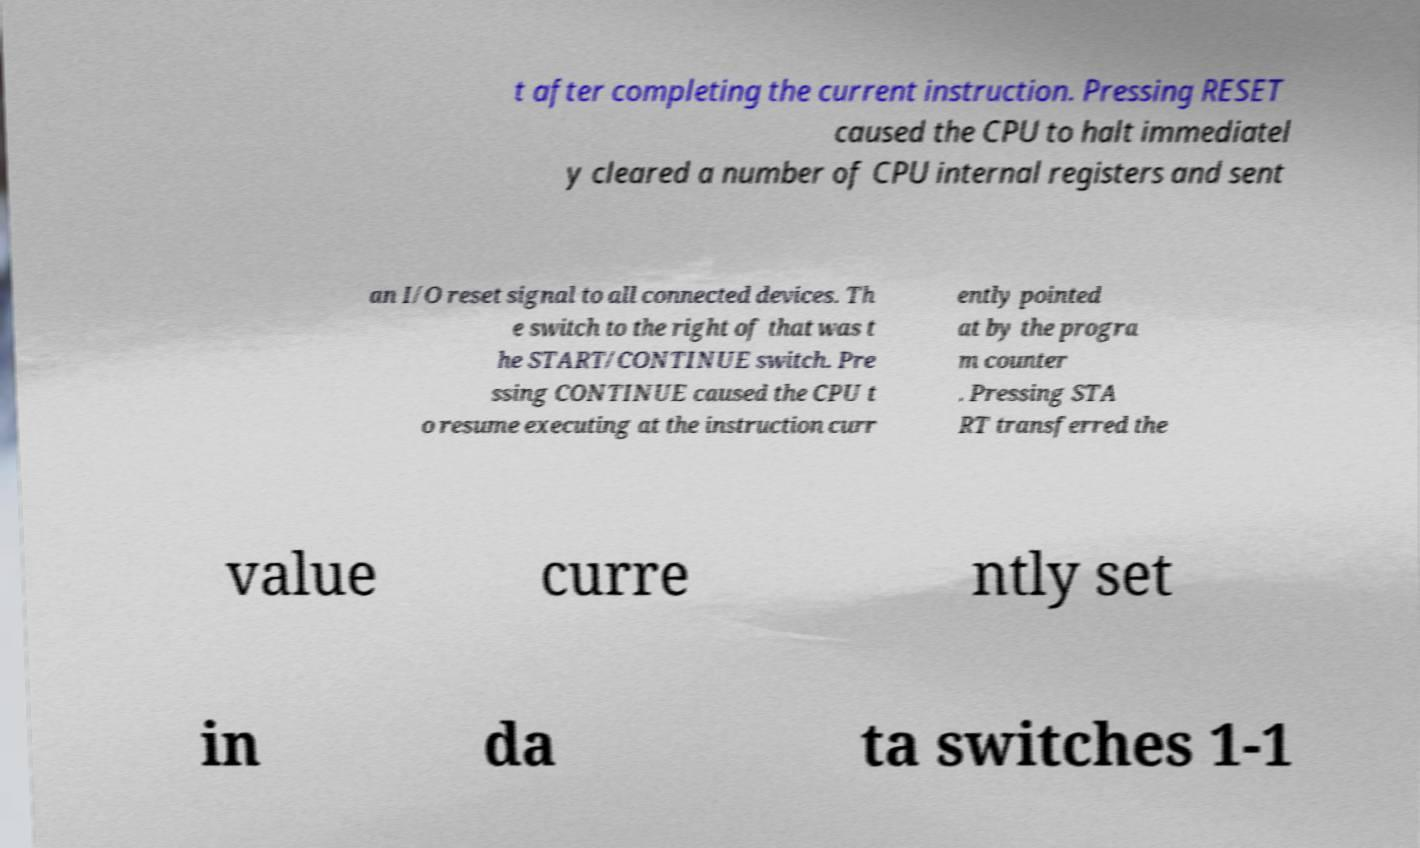I need the written content from this picture converted into text. Can you do that? t after completing the current instruction. Pressing RESET caused the CPU to halt immediatel y cleared a number of CPU internal registers and sent an I/O reset signal to all connected devices. Th e switch to the right of that was t he START/CONTINUE switch. Pre ssing CONTINUE caused the CPU t o resume executing at the instruction curr ently pointed at by the progra m counter . Pressing STA RT transferred the value curre ntly set in da ta switches 1-1 